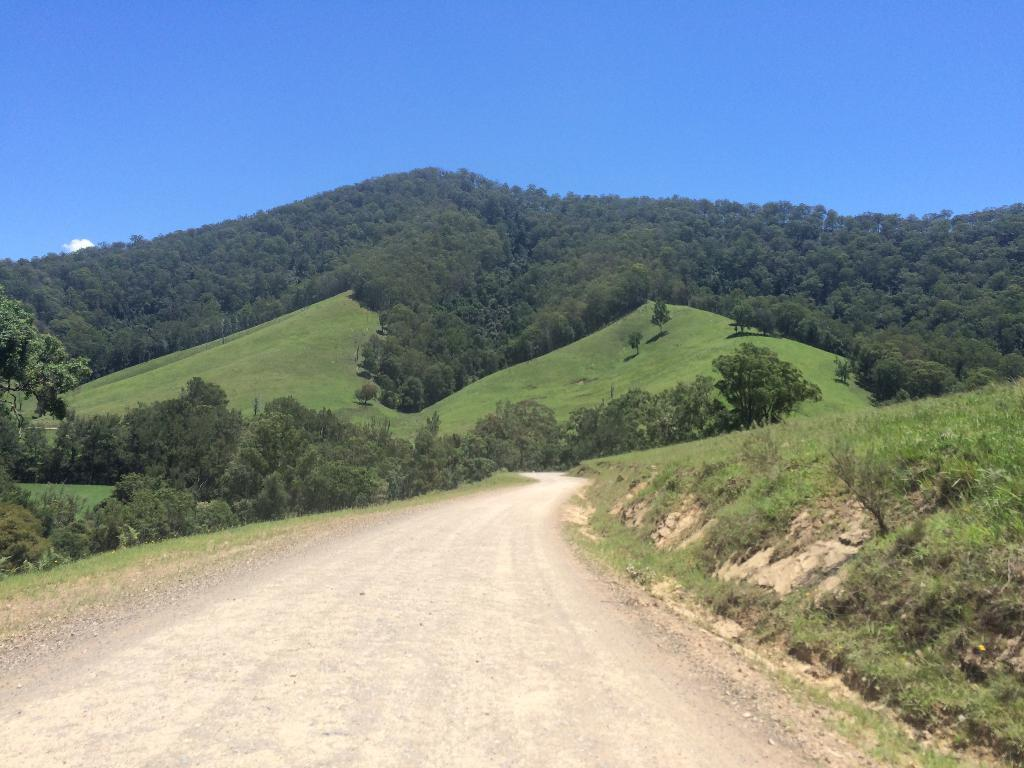What is the main feature in the middle of the image? There is a road in the middle of the image. What can be seen in the background of the image? In the background of the image, there is grass, plants, trees, and a blue sky. Can you describe the natural elements visible in the image? The natural elements in the image include grass, plants, and trees. What is the color of the sky in the image? The sky is blue in the background of the image. Can you see any boats on the road in the image? There are no boats present in the image, as it features a road and natural elements in the background. 